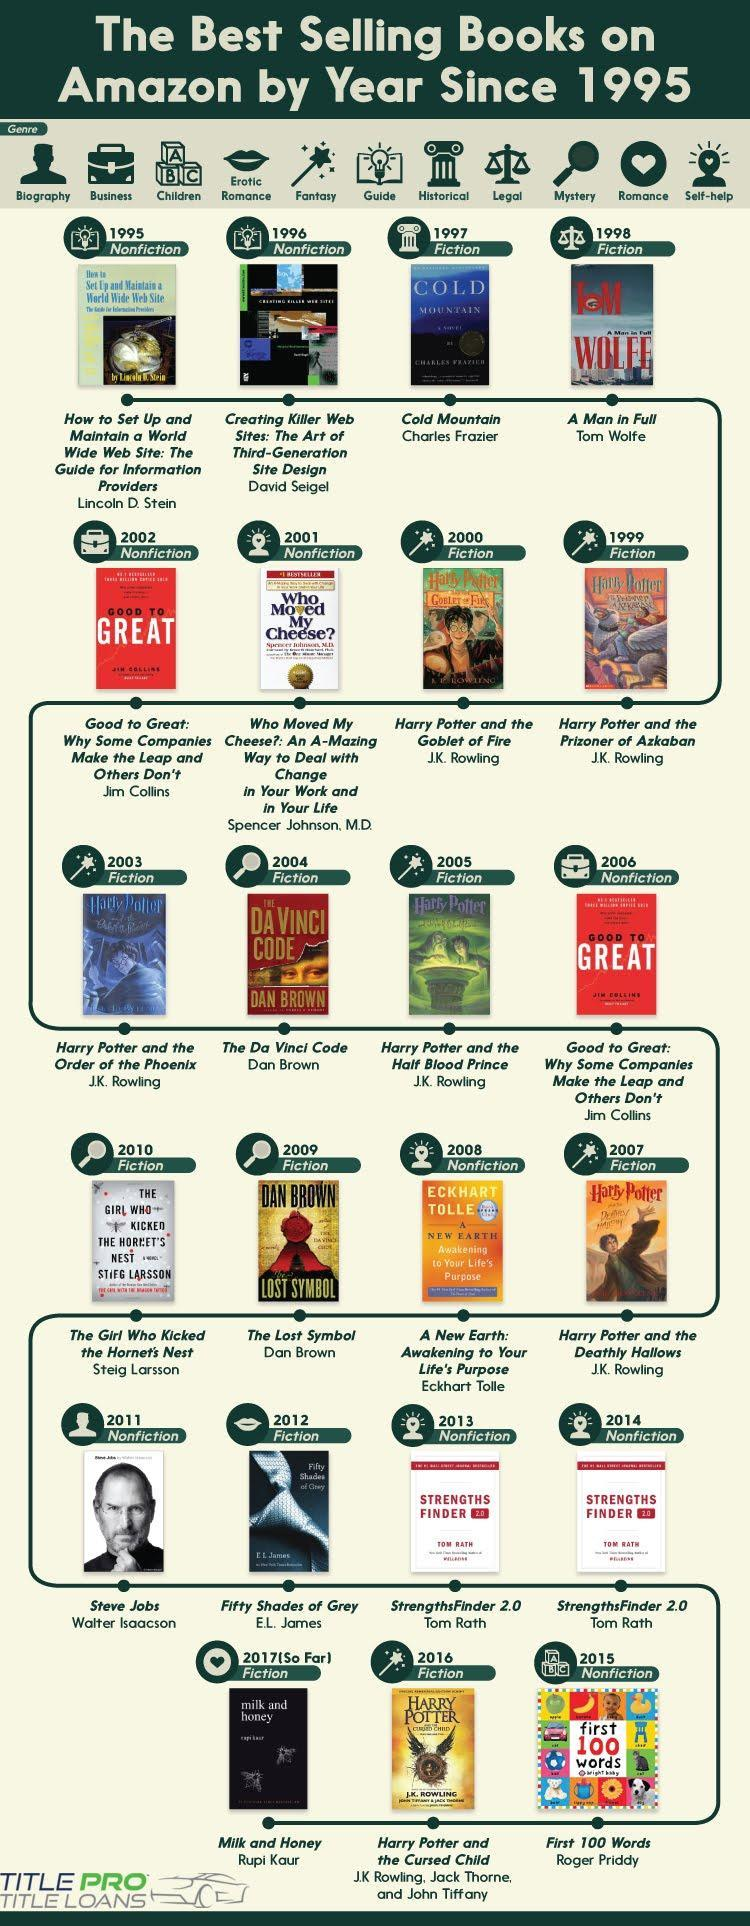Which is the best selling book in the year 1997?
Answer the question with a short phrase. Cold Mountain How many genres are mentioned in this infographic? 11 Who is the author of the book "The Lost Symbol"? Dan Brown How many best selling books are from Dan Brown? 2 What is the genre of the book "A Man in Full"? Fiction How many best selling books from Tom Rath? 2 How many fiction books are in this infographic? 13 How many nonfiction books are in this infographic? 10 Which are the best selling books from Dan Brown? The Lost Symbol, The Da Vinci Code How many best selling books from Jim Collins? 2 